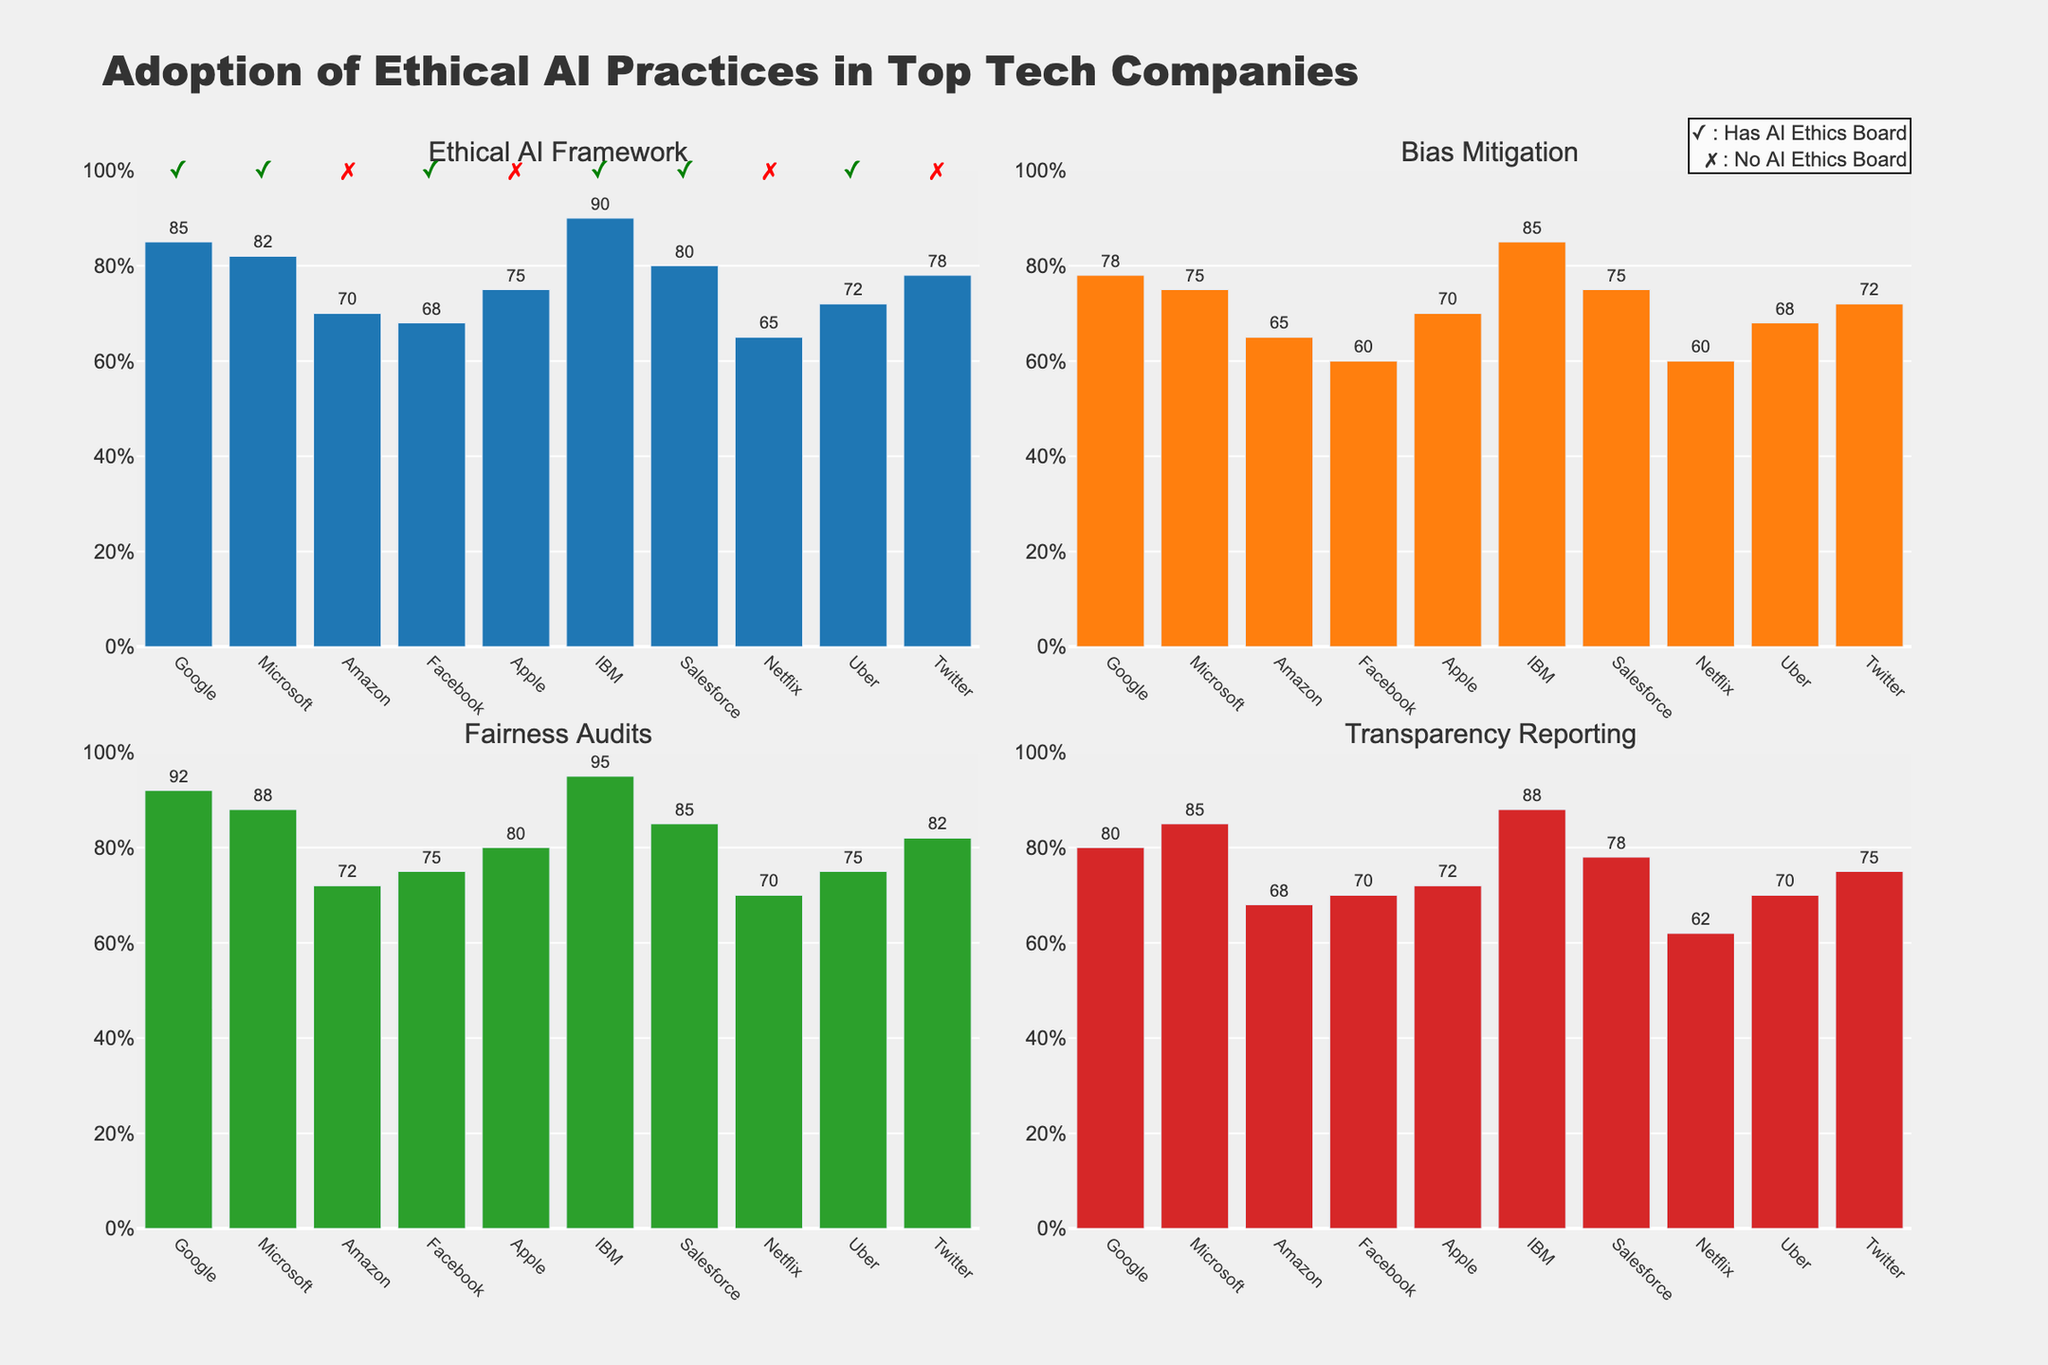What is the title of the figure? The title is usually found at the top of the figure. In this case, it says "Adoption of Ethical AI Practices in Top Tech Companies."
Answer: Adoption of Ethical AI Practices in Top Tech Companies Which company has the highest adoption rate for Bias Mitigation practices? Refer to the subplot labeled "Bias Mitigation" and look for the tallest bar. IBM has the tallest bar with 85%.
Answer: IBM How many companies have an adoption rate of 70% or higher in Transparency Reporting? In the Transparency Reporting subplot, count the number of bars that reach or surpass the 70% mark. There are 6 companies: Google, Microsoft, Facebook, Apple, IBM, and Salesforce.
Answer: 6 What is the difference in the adoption rate of Ethical AI Framework between Google and Amazon? In the Ethical AI Framework subplot, find the values for Google (85%) and Amazon (70%), then compute the difference. 85% - 70% = 15%.
Answer: 15% Which companies have an AI Ethics Board? The companies with checkmarks next to their names in the first subplot indicate the presence of an AI Ethics Board. These companies are Google, Microsoft, Facebook, IBM, Salesforce, and Uber.
Answer: Google, Microsoft, Facebook, IBM, Salesforce, Uber On average, how well are the top tech companies performing in Fairness Audits? Refer to the Fairness Audits subplot and take an average of all the values. (92 + 88 + 72 + 75 + 80 + 95 + 85 + 70 + 75 + 82) / 10 = 81.4%.
Answer: 81.4% Which company has the lowest adoption rate for Transparency Reporting, and what is that rate? In the Transparency Reporting subplot, find the shortest bar which corresponds to Netflix at 62%.
Answer: Netflix, 62% Compare the adoption rate of Fairness Audits and Bias Mitigation for Apple. Which is higher, and by how much? Find the values for Apple in both subplots: Fairness Audits (80%) and Bias Mitigation (70%). Fairness Audits is higher by 10%.
Answer: Fairness Audits, 10% Identify the companies that have a higher rate of Bias Mitigation than Transparency Reporting. Compare the heights of the bars for Bias Mitigation and Transparency Reporting subplots for each company. The companies are Google, IBM, and Uber.
Answer: Google, IBM, Uber 